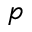Convert formula to latex. <formula><loc_0><loc_0><loc_500><loc_500>p</formula> 